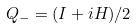Convert formula to latex. <formula><loc_0><loc_0><loc_500><loc_500>Q _ { - } = ( I + i H ) / 2</formula> 